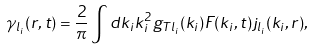Convert formula to latex. <formula><loc_0><loc_0><loc_500><loc_500>\gamma _ { l _ { i } } ( r , t ) = \frac { 2 } { \pi } \int d k _ { i } k _ { i } ^ { 2 } g _ { T l _ { i } } ( k _ { i } ) F ( k _ { i } , t ) j _ { l _ { i } } ( k _ { i } , r ) ,</formula> 